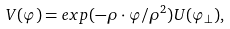Convert formula to latex. <formula><loc_0><loc_0><loc_500><loc_500>V ( \varphi ) = e x p ( - \rho \cdot \varphi / \rho ^ { 2 } ) U ( \varphi _ { \perp } ) ,</formula> 